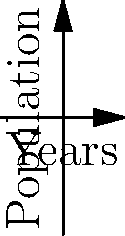The graph shows population trends for downtown and suburban areas of a city over 10 years. The blue line represents downtown, and the red line represents the suburbs. Using the concept of slope, which area is experiencing faster population growth, and by how many people per year? To determine which area is experiencing faster population growth, we need to compare the slopes of the two lines. The slope represents the rate of change in population per year.

1. For the downtown area (blue line):
   Initial population: $y_1 = 50000$
   Final population: $y_2 = 50000 + 2000 * 10 = 70000$
   Slope = $\frac{y_2 - y_1}{x_2 - x_1} = \frac{70000 - 50000}{10 - 0} = \frac{20000}{10} = 2000$ people/year

2. For the suburban area (red line):
   Initial population: $y_1 = 40000$
   Final population: $y_2 = 40000 + 3000 * 10 = 70000$
   Slope = $\frac{y_2 - y_1}{x_2 - x_1} = \frac{70000 - 40000}{10 - 0} = \frac{30000}{10} = 3000$ people/year

3. Comparing the slopes:
   Suburban slope (3000) > Downtown slope (2000)

4. Difference in growth rates:
   $3000 - 2000 = 1000$ people/year

Therefore, the suburban area is experiencing faster population growth, with a rate 1000 people per year higher than the downtown area.
Answer: Suburbs; 1000 people/year faster 